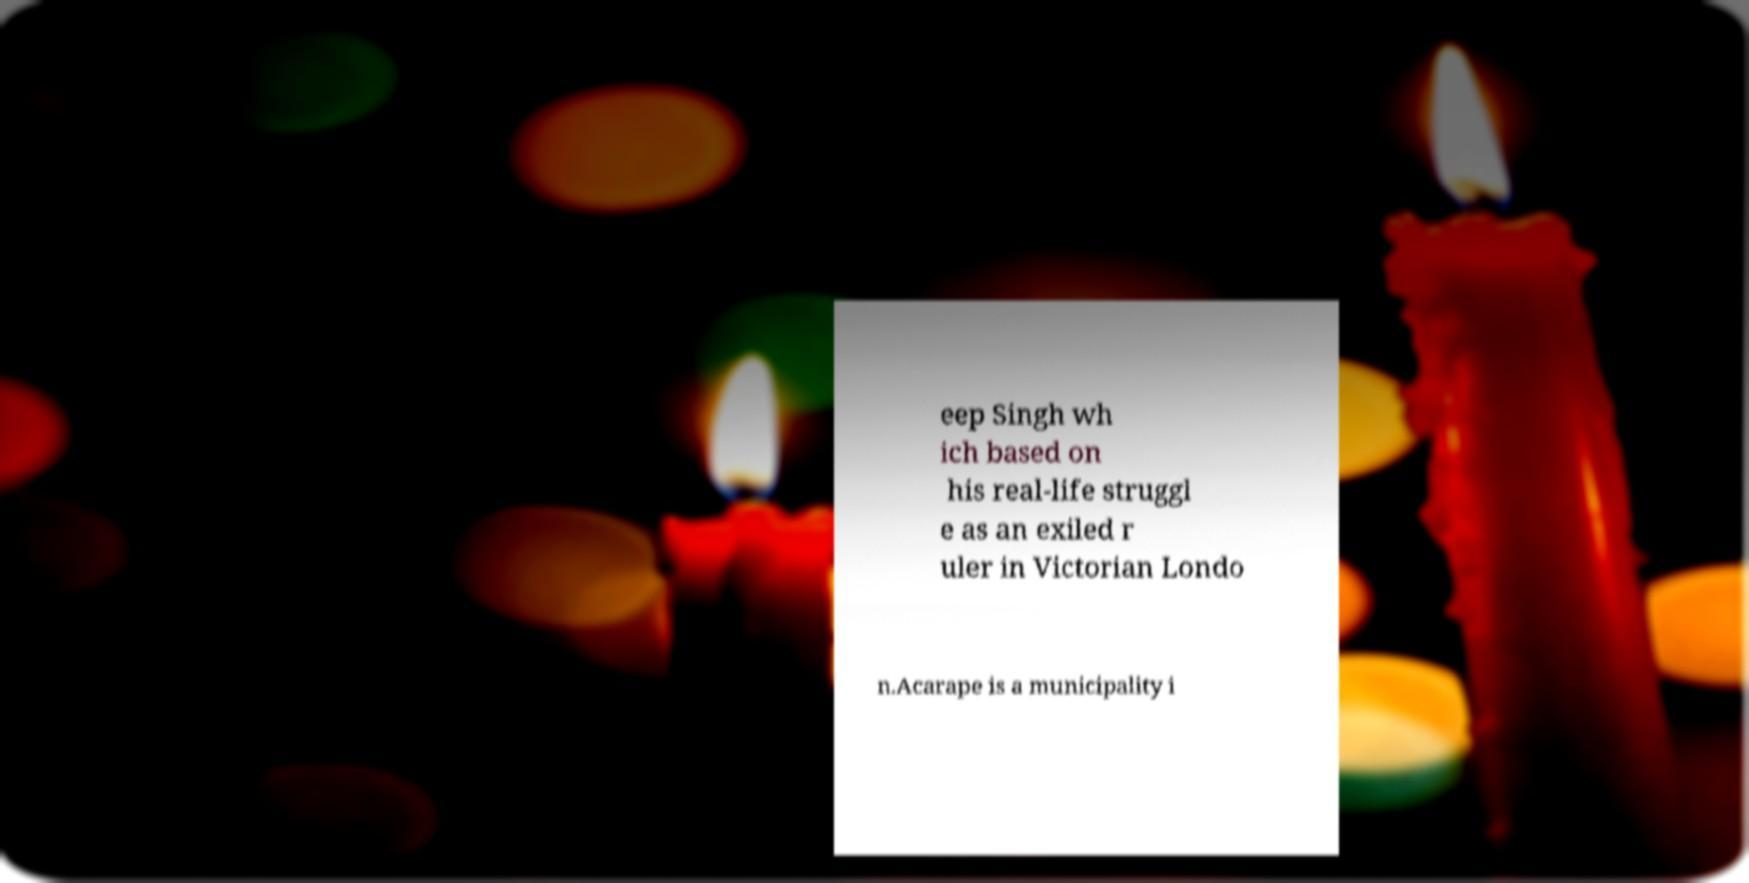Can you accurately transcribe the text from the provided image for me? eep Singh wh ich based on his real-life struggl e as an exiled r uler in Victorian Londo n.Acarape is a municipality i 